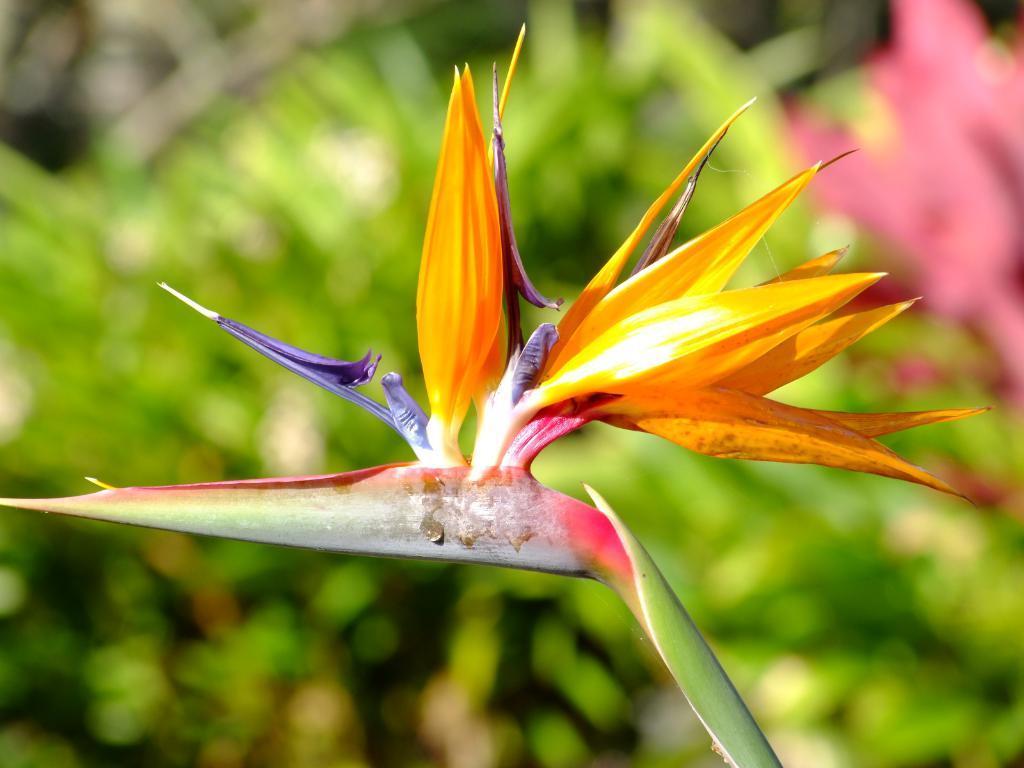Describe this image in one or two sentences. In the image there is flower to a plant, in the back there are plants. 